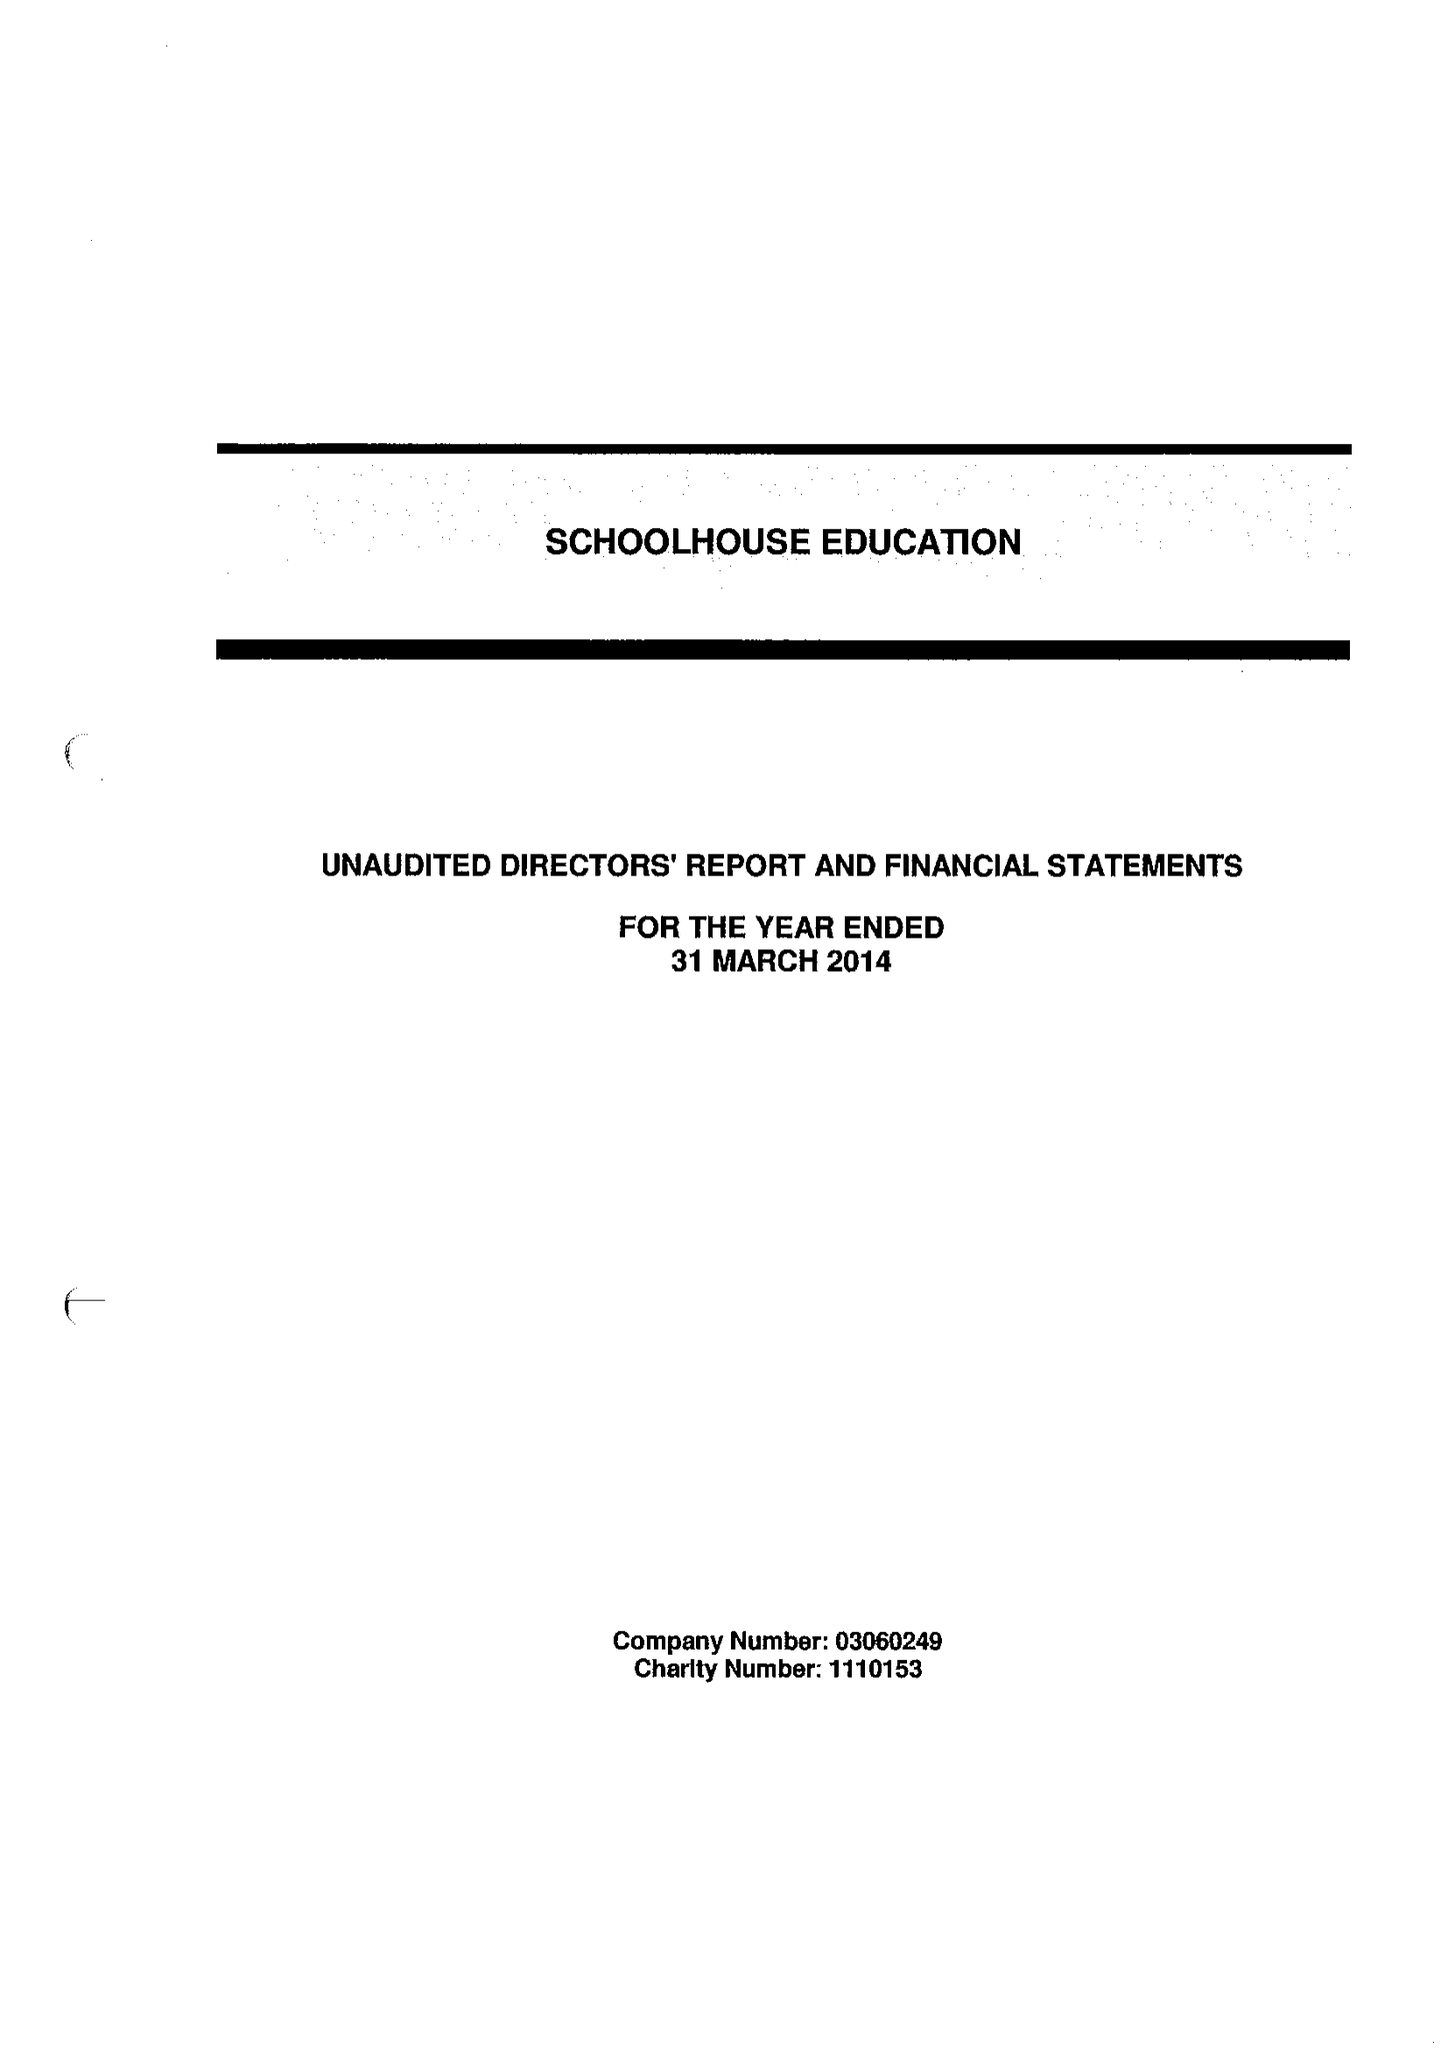What is the value for the report_date?
Answer the question using a single word or phrase. 2014-03-31 